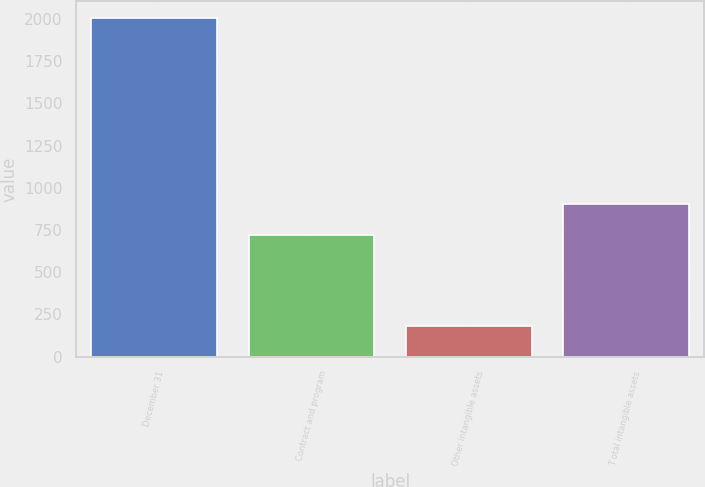Convert chart to OTSL. <chart><loc_0><loc_0><loc_500><loc_500><bar_chart><fcel>December 31<fcel>Contract and program<fcel>Other intangible assets<fcel>T otal intangible assets<nl><fcel>2005<fcel>719<fcel>179<fcel>901.6<nl></chart> 